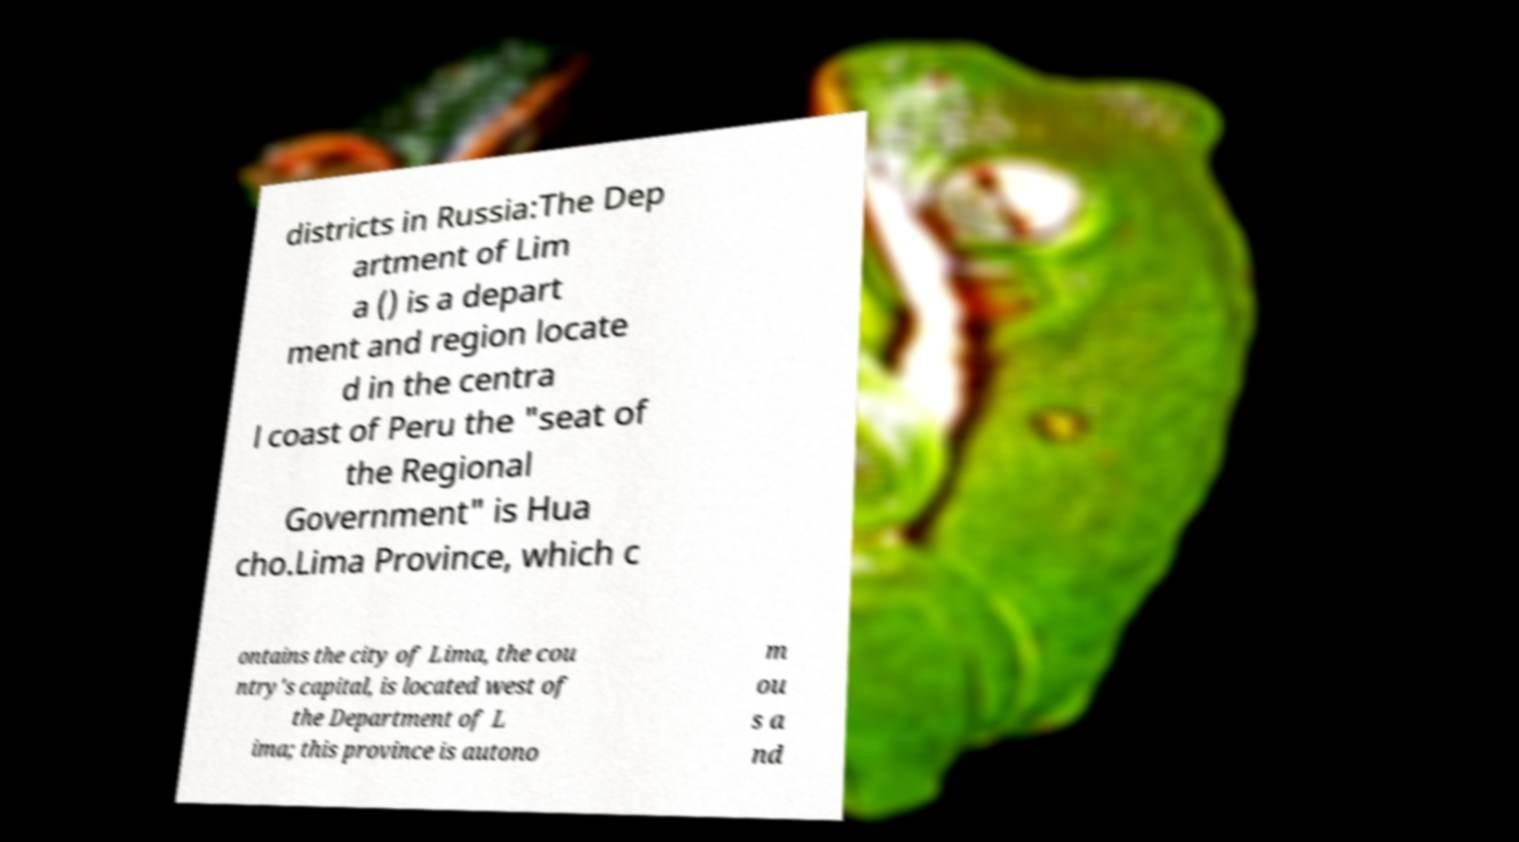What messages or text are displayed in this image? I need them in a readable, typed format. districts in Russia:The Dep artment of Lim a () is a depart ment and region locate d in the centra l coast of Peru the "seat of the Regional Government" is Hua cho.Lima Province, which c ontains the city of Lima, the cou ntry's capital, is located west of the Department of L ima; this province is autono m ou s a nd 